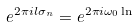<formula> <loc_0><loc_0><loc_500><loc_500>e ^ { 2 \pi i l \sigma _ { n } } = e ^ { 2 \pi i \omega _ { 0 } \ln }</formula> 